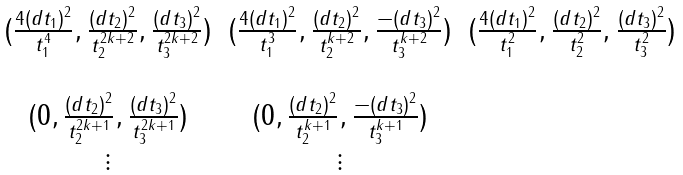<formula> <loc_0><loc_0><loc_500><loc_500>\begin{matrix} ( \frac { 4 ( d t _ { 1 } ) ^ { 2 } } { t _ { 1 } ^ { 4 } } , \frac { ( d t _ { 2 } ) ^ { 2 } } { t _ { 2 } ^ { 2 k + 2 } } , \frac { ( d t _ { 3 } ) ^ { 2 } } { t _ { 3 } ^ { 2 k + 2 } } ) & ( \frac { 4 ( d t _ { 1 } ) ^ { 2 } } { t _ { 1 } ^ { 3 } } , \frac { ( d t _ { 2 } ) ^ { 2 } } { t _ { 2 } ^ { k + 2 } } , \frac { - ( d t _ { 3 } ) ^ { 2 } } { t _ { 3 } ^ { k + 2 } } ) & ( \frac { 4 ( d t _ { 1 } ) ^ { 2 } } { t _ { 1 } ^ { 2 } } , \frac { ( d t _ { 2 } ) ^ { 2 } } { t _ { 2 } ^ { 2 } } , \frac { ( d t _ { 3 } ) ^ { 2 } } { t _ { 3 } ^ { 2 } } ) \\ & & \\ ( 0 , \frac { ( d t _ { 2 } ) ^ { 2 } } { t _ { 2 } ^ { 2 k + 1 } } , \frac { ( d t _ { 3 } ) ^ { 2 } } { t _ { 3 } ^ { 2 k + 1 } } ) & ( 0 , \frac { ( d t _ { 2 } ) ^ { 2 } } { t _ { 2 } ^ { k + 1 } } , \frac { - ( d t _ { 3 } ) ^ { 2 } } { t _ { 3 } ^ { k + 1 } } ) & \\ \vdots & \vdots & \\ \end{matrix}</formula> 